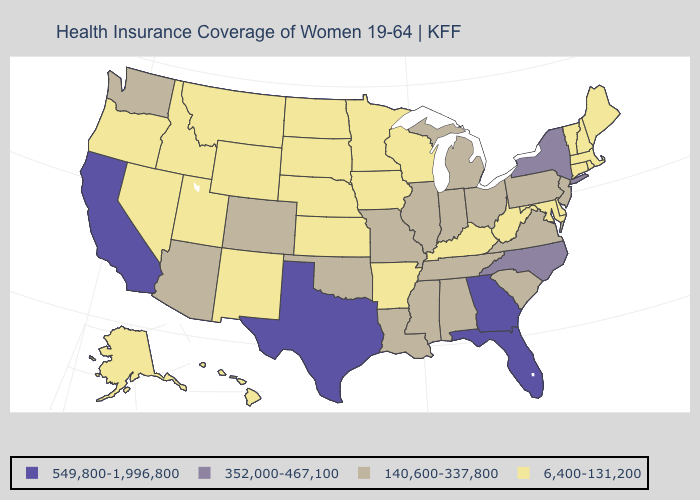What is the lowest value in the Northeast?
Quick response, please. 6,400-131,200. Name the states that have a value in the range 6,400-131,200?
Quick response, please. Alaska, Arkansas, Connecticut, Delaware, Hawaii, Idaho, Iowa, Kansas, Kentucky, Maine, Maryland, Massachusetts, Minnesota, Montana, Nebraska, Nevada, New Hampshire, New Mexico, North Dakota, Oregon, Rhode Island, South Dakota, Utah, Vermont, West Virginia, Wisconsin, Wyoming. Name the states that have a value in the range 6,400-131,200?
Write a very short answer. Alaska, Arkansas, Connecticut, Delaware, Hawaii, Idaho, Iowa, Kansas, Kentucky, Maine, Maryland, Massachusetts, Minnesota, Montana, Nebraska, Nevada, New Hampshire, New Mexico, North Dakota, Oregon, Rhode Island, South Dakota, Utah, Vermont, West Virginia, Wisconsin, Wyoming. Does the first symbol in the legend represent the smallest category?
Be succinct. No. Does Missouri have a lower value than Georgia?
Short answer required. Yes. Among the states that border Iowa , does Nebraska have the lowest value?
Answer briefly. Yes. What is the value of New Jersey?
Keep it brief. 140,600-337,800. What is the highest value in the South ?
Keep it brief. 549,800-1,996,800. Name the states that have a value in the range 140,600-337,800?
Concise answer only. Alabama, Arizona, Colorado, Illinois, Indiana, Louisiana, Michigan, Mississippi, Missouri, New Jersey, Ohio, Oklahoma, Pennsylvania, South Carolina, Tennessee, Virginia, Washington. Name the states that have a value in the range 352,000-467,100?
Give a very brief answer. New York, North Carolina. What is the value of Rhode Island?
Answer briefly. 6,400-131,200. Does the map have missing data?
Keep it brief. No. What is the highest value in the USA?
Quick response, please. 549,800-1,996,800. Does New York have the lowest value in the Northeast?
Write a very short answer. No. Name the states that have a value in the range 352,000-467,100?
Short answer required. New York, North Carolina. 